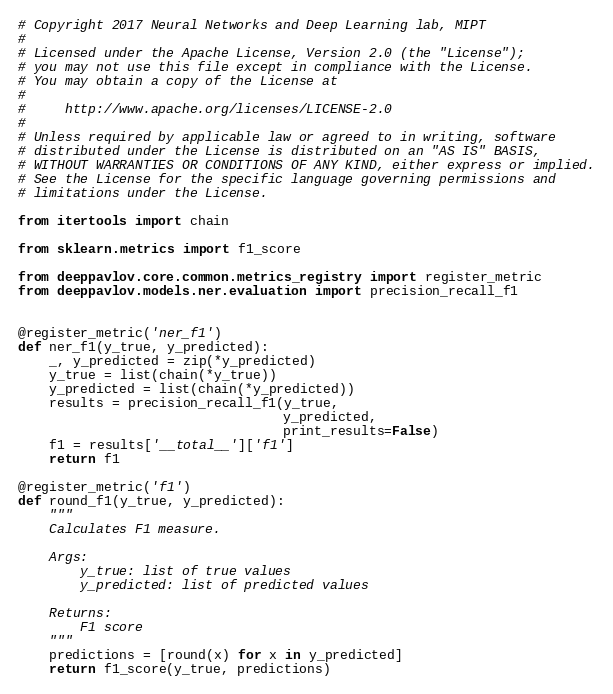Convert code to text. <code><loc_0><loc_0><loc_500><loc_500><_Python_># Copyright 2017 Neural Networks and Deep Learning lab, MIPT
#
# Licensed under the Apache License, Version 2.0 (the "License");
# you may not use this file except in compliance with the License.
# You may obtain a copy of the License at
#
#     http://www.apache.org/licenses/LICENSE-2.0
#
# Unless required by applicable law or agreed to in writing, software
# distributed under the License is distributed on an "AS IS" BASIS,
# WITHOUT WARRANTIES OR CONDITIONS OF ANY KIND, either express or implied.
# See the License for the specific language governing permissions and
# limitations under the License.

from itertools import chain

from sklearn.metrics import f1_score

from deeppavlov.core.common.metrics_registry import register_metric
from deeppavlov.models.ner.evaluation import precision_recall_f1


@register_metric('ner_f1')
def ner_f1(y_true, y_predicted):
    _, y_predicted = zip(*y_predicted)
    y_true = list(chain(*y_true))
    y_predicted = list(chain(*y_predicted))
    results = precision_recall_f1(y_true,
                                  y_predicted,
                                  print_results=False)
    f1 = results['__total__']['f1']
    return f1

@register_metric('f1')
def round_f1(y_true, y_predicted):
    """
    Calculates F1 measure.

    Args:
        y_true: list of true values
        y_predicted: list of predicted values

    Returns:
        F1 score
    """
    predictions = [round(x) for x in y_predicted]
    return f1_score(y_true, predictions)

</code> 